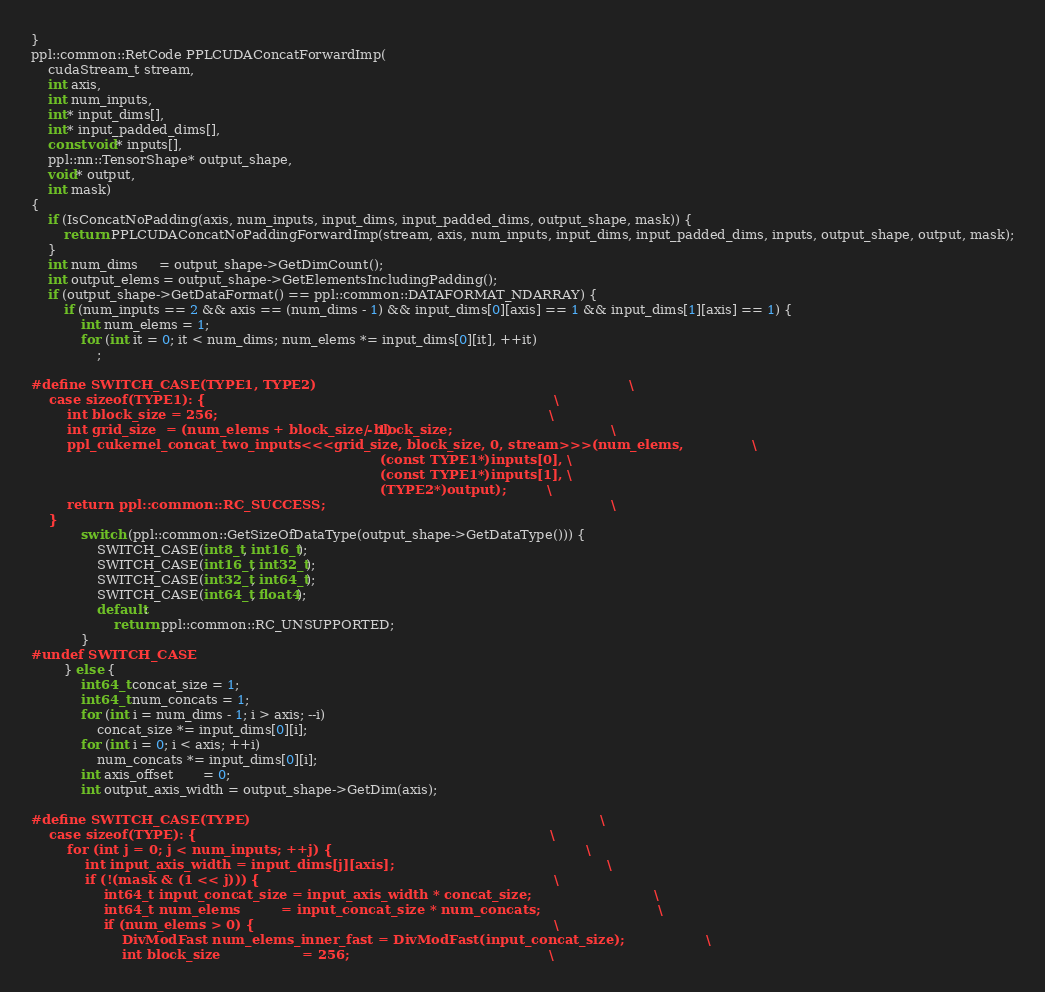<code> <loc_0><loc_0><loc_500><loc_500><_Cuda_>}
ppl::common::RetCode PPLCUDAConcatForwardImp(
    cudaStream_t stream,
    int axis,
    int num_inputs,
    int* input_dims[],
    int* input_padded_dims[],
    const void* inputs[],
    ppl::nn::TensorShape* output_shape,
    void* output,
    int mask)
{
    if (IsConcatNoPadding(axis, num_inputs, input_dims, input_padded_dims, output_shape, mask)) {
        return PPLCUDAConcatNoPaddingForwardImp(stream, axis, num_inputs, input_dims, input_padded_dims, inputs, output_shape, output, mask);
    }
    int num_dims     = output_shape->GetDimCount();
    int output_elems = output_shape->GetElementsIncludingPadding();
    if (output_shape->GetDataFormat() == ppl::common::DATAFORMAT_NDARRAY) {
        if (num_inputs == 2 && axis == (num_dims - 1) && input_dims[0][axis] == 1 && input_dims[1][axis] == 1) {
            int num_elems = 1;
            for (int it = 0; it < num_dims; num_elems *= input_dims[0][it], ++it)
                ;

#define SWITCH_CASE(TYPE1, TYPE2)                                                                     \
    case sizeof(TYPE1): {                                                                             \
        int block_size = 256;                                                                         \
        int grid_size  = (num_elems + block_size - 1) / block_size;                                   \
        ppl_cukernel_concat_two_inputs<<<grid_size, block_size, 0, stream>>>(num_elems,               \
                                                                             (const TYPE1*)inputs[0], \
                                                                             (const TYPE1*)inputs[1], \
                                                                             (TYPE2*)output);         \
        return ppl::common::RC_SUCCESS;                                                               \
    }
            switch (ppl::common::GetSizeOfDataType(output_shape->GetDataType())) {
                SWITCH_CASE(int8_t, int16_t);
                SWITCH_CASE(int16_t, int32_t);
                SWITCH_CASE(int32_t, int64_t);
                SWITCH_CASE(int64_t, float4);
                default:
                    return ppl::common::RC_UNSUPPORTED;
            }
#undef SWITCH_CASE
        } else {
            int64_t concat_size = 1;
            int64_t num_concats = 1;
            for (int i = num_dims - 1; i > axis; --i)
                concat_size *= input_dims[0][i];
            for (int i = 0; i < axis; ++i)
                num_concats *= input_dims[0][i];
            int axis_offset       = 0;
            int output_axis_width = output_shape->GetDim(axis);

#define SWITCH_CASE(TYPE)                                                                             \
    case sizeof(TYPE): {                                                                              \
        for (int j = 0; j < num_inputs; ++j) {                                                        \
            int input_axis_width = input_dims[j][axis];                                               \
            if (!(mask & (1 << j))) {                                                                 \
                int64_t input_concat_size = input_axis_width * concat_size;                           \
                int64_t num_elems         = input_concat_size * num_concats;                          \
                if (num_elems > 0) {                                                                  \
                    DivModFast num_elems_inner_fast = DivModFast(input_concat_size);                  \
                    int block_size                  = 256;                                            \</code> 